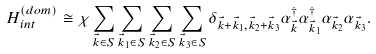<formula> <loc_0><loc_0><loc_500><loc_500>H _ { i n t } ^ { ( d o m ) } \cong \chi \sum _ { \vec { k } \in S } \sum _ { \vec { k } _ { 1 } \in S } \sum _ { \vec { k } _ { 2 } \in S } \sum _ { \vec { k } _ { 3 } \in S } \delta _ { \vec { k } + \vec { k } _ { 1 } , \vec { k } _ { 2 } + \vec { k } _ { 3 } } \alpha _ { \vec { k } } ^ { \dagger } \alpha _ { \vec { k } _ { 1 } } ^ { \dagger } \alpha _ { \vec { k } _ { 2 } } \alpha _ { \vec { k } _ { 3 } } .</formula> 